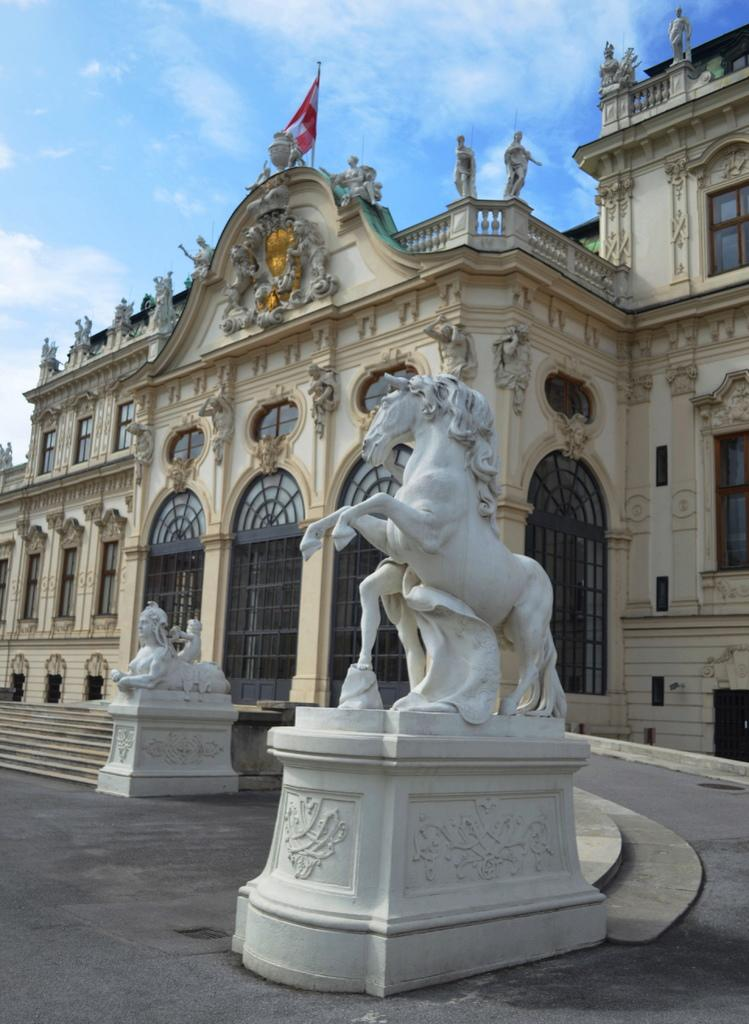What can be seen on the road in the image? There are two white color statues on the road. What is unique about the road in the image? The road has glass windows. What is located at the top of the road? There is a flag on the top of the road. What can be seen in the background of the image? In the background, there are clouds in the blue sky. What type of calculator is being used by the representative in the image? There is no representative or calculator present in the image. What season is depicted in the image based on the clothing of the people? The image does not show any people, so it is not possible to determine the season based on their clothing. 